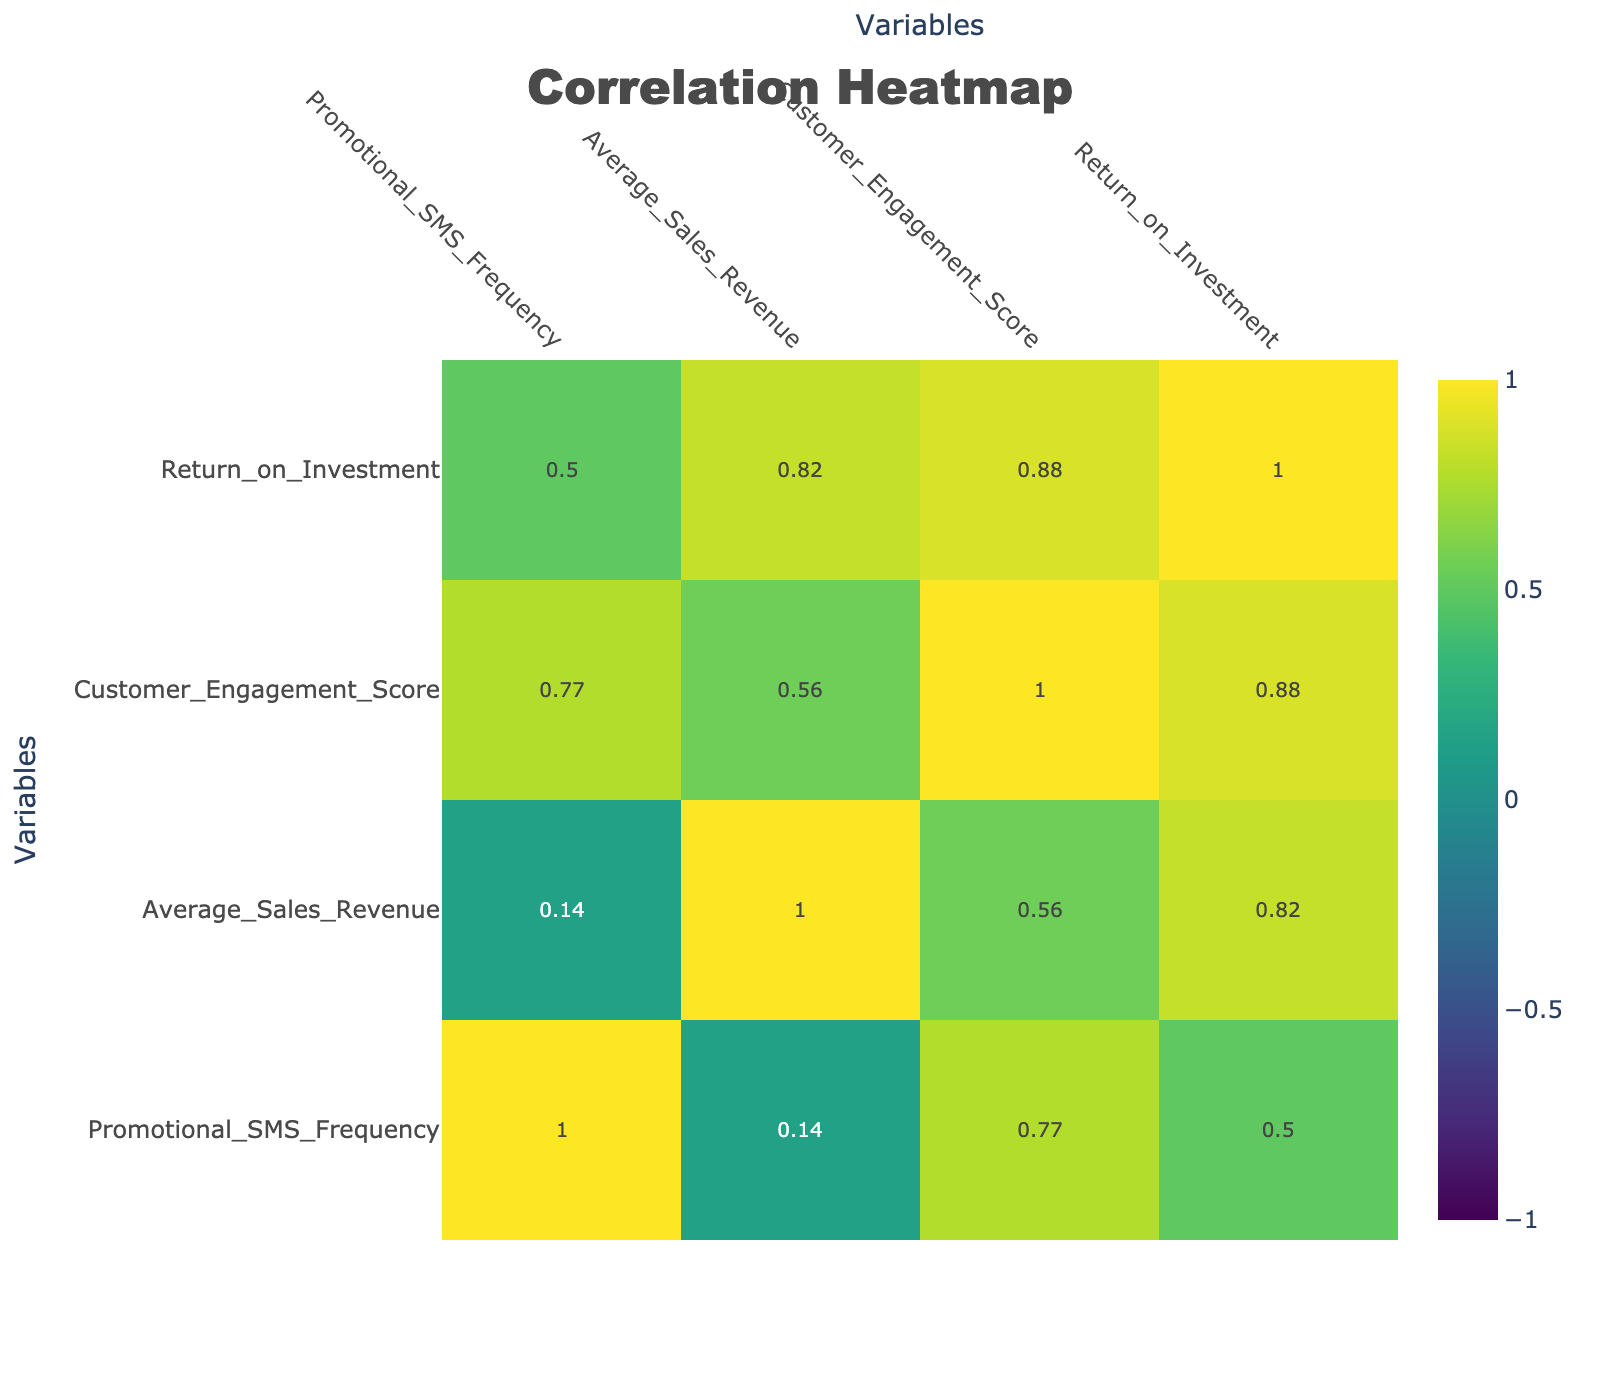What is the correlation between Promotional SMS Frequency and Average Sales Revenue? Referring to the correlation table, we can see the correlation value between Promotional SMS Frequency and Average Sales Revenue. This value shows how closely related these two variables are.
Answer: The correlation is approximately -0.02 Which product category has the highest Average Sales Revenue? Looking at the Average Sales Revenue column in the table, the Home Appliances category has the highest value at 200000.
Answer: Home Appliances Is there a relationship between Customer Engagement Score and Return on Investment? By checking the correlation coefficient for Customer Engagement Score and Return on Investment in the table, we can determine if a relationship exists between these two metrics. The correlation is approximately 0.68, indicating a strong positive relationship.
Answer: Yes Which product category has the lowest Promotional SMS Frequency? Observing the Promotional SMS Frequency column in the table, we see that Automotive has the lowest frequency value of 1.
Answer: Automotive What is the total Average Sales Revenue for product categories with Promotional SMS Frequency greater than 5? First, we identify the product categories with a Promotional SMS Frequency greater than 5, which are Clothing (8), Beauty Products (10), Health Supplements (9), and Toys (7). We then sum their Average Sales Revenues: 120000 + 75000 + 110000 + 95000 = 400000.
Answer: 400000 Does increasing the Promotional SMS Frequency lead to a decrease in the Average Sales Revenue for any product categories? To determine this, we need to examine the correlation between Promotional SMS Frequency and Average Sales Revenue. With a correlation of approximately -0.02, it shows there is no significant relationship indicating that increased SMS frequency does not consistently lead to decreased sales revenue across categories.
Answer: No What is the Average Return on Investment of product categories with a Customer Engagement Score above 75? We first select the product categories with a Customer Engagement Score greater than 75, which are Electronics (80), Home Appliances (85), Beauty Products (90), and Health Supplements (78). Summing their Return on Investment values: 5.2 + 6.5 + 4.0 + 4.7 = 20.4. Dividing by the number of categories (4) gives us an average of 20.4 / 4 = 5.1.
Answer: 5.1 